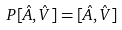<formula> <loc_0><loc_0><loc_500><loc_500>P [ \hat { A } , \hat { V } ] = [ \hat { A } , \hat { V } ]</formula> 